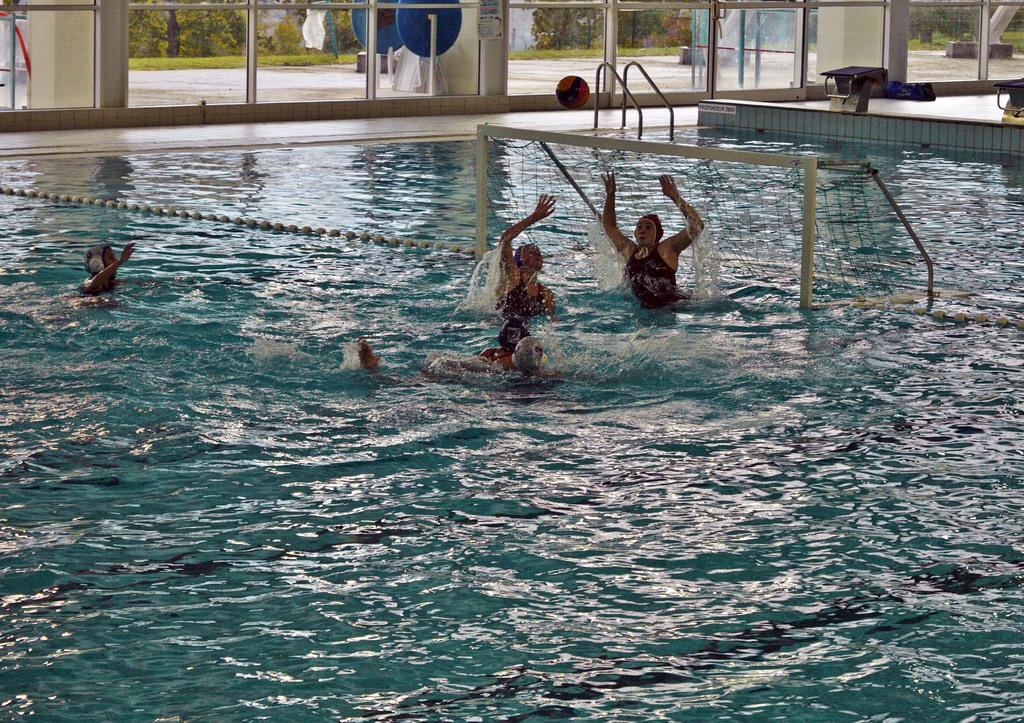What activity are the people engaged in within the swimming pool? The people are playing with a ball in the swimming pool. What type of doors surround the swimming pool? There are glass doors around the swimming pool. What can be seen behind the glass doors? Many trees are visible behind the glass doors. What type of pet can be seen playing with a nail in the image? There is no pet or nail present in the image; it features people playing with a ball in a swimming pool surrounded by glass doors and trees. 